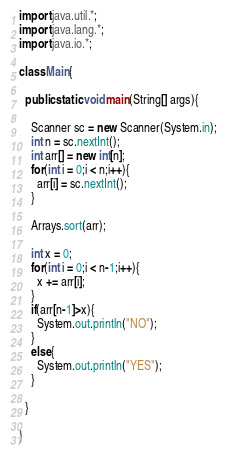<code> <loc_0><loc_0><loc_500><loc_500><_Java_>import java.util.*;
import java.lang.*;
import java.io.*;

class Main{
  
  public static void main(String[] args){
    
    Scanner sc = new Scanner(System.in);
    int n = sc.nextInt();
    int arr[] = new int[n];
    for(int i = 0;i < n;i++){
      arr[i] = sc.nextInt();
    }
    
    Arrays.sort(arr);
    
    int x = 0;
    for(int i = 0;i < n-1;i++){
      x += arr[i];
    }
    if(arr[n-1]>x){
      System.out.println("NO");
    }
    else{
      System.out.println("YES");
    }

  }

}

</code> 